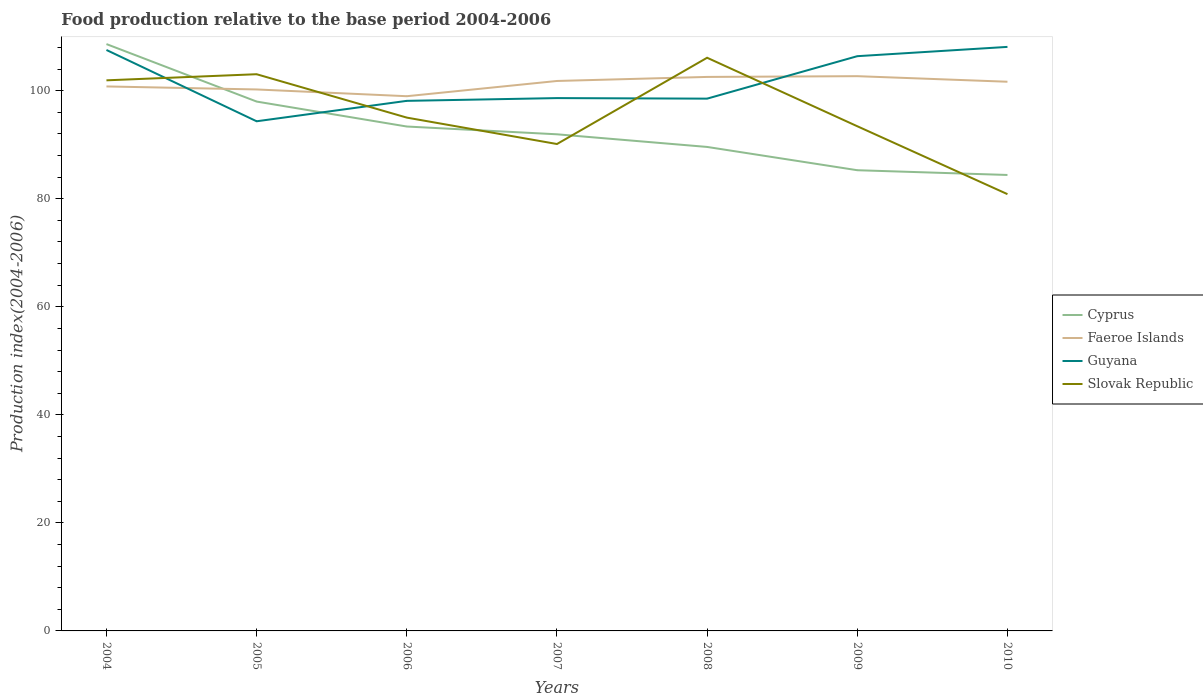Does the line corresponding to Guyana intersect with the line corresponding to Faeroe Islands?
Provide a short and direct response. Yes. Is the number of lines equal to the number of legend labels?
Give a very brief answer. Yes. Across all years, what is the maximum food production index in Cyprus?
Offer a terse response. 84.4. In which year was the food production index in Slovak Republic maximum?
Your answer should be compact. 2010. What is the total food production index in Slovak Republic in the graph?
Give a very brief answer. 1.6. What is the difference between the highest and the second highest food production index in Faeroe Islands?
Provide a succinct answer. 3.71. Does the graph contain grids?
Keep it short and to the point. No. How many legend labels are there?
Keep it short and to the point. 4. What is the title of the graph?
Your response must be concise. Food production relative to the base period 2004-2006. What is the label or title of the X-axis?
Make the answer very short. Years. What is the label or title of the Y-axis?
Ensure brevity in your answer.  Production index(2004-2006). What is the Production index(2004-2006) of Cyprus in 2004?
Offer a very short reply. 108.63. What is the Production index(2004-2006) in Faeroe Islands in 2004?
Ensure brevity in your answer.  100.79. What is the Production index(2004-2006) in Guyana in 2004?
Your answer should be very brief. 107.54. What is the Production index(2004-2006) in Slovak Republic in 2004?
Provide a succinct answer. 101.92. What is the Production index(2004-2006) of Cyprus in 2005?
Offer a very short reply. 97.99. What is the Production index(2004-2006) of Faeroe Islands in 2005?
Provide a succinct answer. 100.23. What is the Production index(2004-2006) in Guyana in 2005?
Provide a short and direct response. 94.34. What is the Production index(2004-2006) of Slovak Republic in 2005?
Make the answer very short. 103.05. What is the Production index(2004-2006) in Cyprus in 2006?
Provide a succinct answer. 93.37. What is the Production index(2004-2006) of Faeroe Islands in 2006?
Your answer should be compact. 98.98. What is the Production index(2004-2006) of Guyana in 2006?
Make the answer very short. 98.12. What is the Production index(2004-2006) of Slovak Republic in 2006?
Provide a short and direct response. 95.02. What is the Production index(2004-2006) in Cyprus in 2007?
Make the answer very short. 91.93. What is the Production index(2004-2006) in Faeroe Islands in 2007?
Your response must be concise. 101.8. What is the Production index(2004-2006) in Guyana in 2007?
Ensure brevity in your answer.  98.63. What is the Production index(2004-2006) of Slovak Republic in 2007?
Keep it short and to the point. 90.13. What is the Production index(2004-2006) in Cyprus in 2008?
Your response must be concise. 89.59. What is the Production index(2004-2006) of Faeroe Islands in 2008?
Give a very brief answer. 102.55. What is the Production index(2004-2006) in Guyana in 2008?
Keep it short and to the point. 98.53. What is the Production index(2004-2006) in Slovak Republic in 2008?
Provide a short and direct response. 106.1. What is the Production index(2004-2006) in Cyprus in 2009?
Your answer should be very brief. 85.28. What is the Production index(2004-2006) of Faeroe Islands in 2009?
Your response must be concise. 102.69. What is the Production index(2004-2006) of Guyana in 2009?
Make the answer very short. 106.39. What is the Production index(2004-2006) in Slovak Republic in 2009?
Offer a very short reply. 93.42. What is the Production index(2004-2006) in Cyprus in 2010?
Make the answer very short. 84.4. What is the Production index(2004-2006) in Faeroe Islands in 2010?
Make the answer very short. 101.66. What is the Production index(2004-2006) in Guyana in 2010?
Your response must be concise. 108.11. What is the Production index(2004-2006) in Slovak Republic in 2010?
Ensure brevity in your answer.  80.85. Across all years, what is the maximum Production index(2004-2006) of Cyprus?
Offer a very short reply. 108.63. Across all years, what is the maximum Production index(2004-2006) of Faeroe Islands?
Your answer should be compact. 102.69. Across all years, what is the maximum Production index(2004-2006) of Guyana?
Provide a succinct answer. 108.11. Across all years, what is the maximum Production index(2004-2006) of Slovak Republic?
Provide a short and direct response. 106.1. Across all years, what is the minimum Production index(2004-2006) of Cyprus?
Your answer should be compact. 84.4. Across all years, what is the minimum Production index(2004-2006) of Faeroe Islands?
Ensure brevity in your answer.  98.98. Across all years, what is the minimum Production index(2004-2006) in Guyana?
Your answer should be compact. 94.34. Across all years, what is the minimum Production index(2004-2006) of Slovak Republic?
Your answer should be compact. 80.85. What is the total Production index(2004-2006) of Cyprus in the graph?
Provide a succinct answer. 651.19. What is the total Production index(2004-2006) in Faeroe Islands in the graph?
Make the answer very short. 708.7. What is the total Production index(2004-2006) of Guyana in the graph?
Offer a terse response. 711.66. What is the total Production index(2004-2006) in Slovak Republic in the graph?
Offer a terse response. 670.49. What is the difference between the Production index(2004-2006) in Cyprus in 2004 and that in 2005?
Your answer should be very brief. 10.64. What is the difference between the Production index(2004-2006) of Faeroe Islands in 2004 and that in 2005?
Provide a short and direct response. 0.56. What is the difference between the Production index(2004-2006) of Guyana in 2004 and that in 2005?
Provide a short and direct response. 13.2. What is the difference between the Production index(2004-2006) of Slovak Republic in 2004 and that in 2005?
Offer a very short reply. -1.13. What is the difference between the Production index(2004-2006) of Cyprus in 2004 and that in 2006?
Provide a short and direct response. 15.26. What is the difference between the Production index(2004-2006) of Faeroe Islands in 2004 and that in 2006?
Give a very brief answer. 1.81. What is the difference between the Production index(2004-2006) of Guyana in 2004 and that in 2006?
Give a very brief answer. 9.42. What is the difference between the Production index(2004-2006) in Slovak Republic in 2004 and that in 2006?
Provide a succinct answer. 6.9. What is the difference between the Production index(2004-2006) in Cyprus in 2004 and that in 2007?
Give a very brief answer. 16.7. What is the difference between the Production index(2004-2006) of Faeroe Islands in 2004 and that in 2007?
Ensure brevity in your answer.  -1.01. What is the difference between the Production index(2004-2006) in Guyana in 2004 and that in 2007?
Your answer should be compact. 8.91. What is the difference between the Production index(2004-2006) of Slovak Republic in 2004 and that in 2007?
Offer a terse response. 11.79. What is the difference between the Production index(2004-2006) of Cyprus in 2004 and that in 2008?
Make the answer very short. 19.04. What is the difference between the Production index(2004-2006) in Faeroe Islands in 2004 and that in 2008?
Give a very brief answer. -1.76. What is the difference between the Production index(2004-2006) in Guyana in 2004 and that in 2008?
Provide a short and direct response. 9.01. What is the difference between the Production index(2004-2006) in Slovak Republic in 2004 and that in 2008?
Provide a succinct answer. -4.18. What is the difference between the Production index(2004-2006) in Cyprus in 2004 and that in 2009?
Provide a short and direct response. 23.35. What is the difference between the Production index(2004-2006) in Guyana in 2004 and that in 2009?
Offer a terse response. 1.15. What is the difference between the Production index(2004-2006) of Cyprus in 2004 and that in 2010?
Your response must be concise. 24.23. What is the difference between the Production index(2004-2006) in Faeroe Islands in 2004 and that in 2010?
Ensure brevity in your answer.  -0.87. What is the difference between the Production index(2004-2006) in Guyana in 2004 and that in 2010?
Ensure brevity in your answer.  -0.57. What is the difference between the Production index(2004-2006) in Slovak Republic in 2004 and that in 2010?
Offer a very short reply. 21.07. What is the difference between the Production index(2004-2006) of Cyprus in 2005 and that in 2006?
Provide a succinct answer. 4.62. What is the difference between the Production index(2004-2006) of Faeroe Islands in 2005 and that in 2006?
Provide a short and direct response. 1.25. What is the difference between the Production index(2004-2006) in Guyana in 2005 and that in 2006?
Offer a very short reply. -3.78. What is the difference between the Production index(2004-2006) in Slovak Republic in 2005 and that in 2006?
Provide a short and direct response. 8.03. What is the difference between the Production index(2004-2006) of Cyprus in 2005 and that in 2007?
Your response must be concise. 6.06. What is the difference between the Production index(2004-2006) of Faeroe Islands in 2005 and that in 2007?
Make the answer very short. -1.57. What is the difference between the Production index(2004-2006) of Guyana in 2005 and that in 2007?
Your answer should be very brief. -4.29. What is the difference between the Production index(2004-2006) in Slovak Republic in 2005 and that in 2007?
Offer a very short reply. 12.92. What is the difference between the Production index(2004-2006) of Faeroe Islands in 2005 and that in 2008?
Your response must be concise. -2.32. What is the difference between the Production index(2004-2006) in Guyana in 2005 and that in 2008?
Your answer should be very brief. -4.19. What is the difference between the Production index(2004-2006) in Slovak Republic in 2005 and that in 2008?
Ensure brevity in your answer.  -3.05. What is the difference between the Production index(2004-2006) of Cyprus in 2005 and that in 2009?
Your answer should be compact. 12.71. What is the difference between the Production index(2004-2006) in Faeroe Islands in 2005 and that in 2009?
Provide a succinct answer. -2.46. What is the difference between the Production index(2004-2006) of Guyana in 2005 and that in 2009?
Keep it short and to the point. -12.05. What is the difference between the Production index(2004-2006) of Slovak Republic in 2005 and that in 2009?
Give a very brief answer. 9.63. What is the difference between the Production index(2004-2006) in Cyprus in 2005 and that in 2010?
Keep it short and to the point. 13.59. What is the difference between the Production index(2004-2006) of Faeroe Islands in 2005 and that in 2010?
Give a very brief answer. -1.43. What is the difference between the Production index(2004-2006) of Guyana in 2005 and that in 2010?
Ensure brevity in your answer.  -13.77. What is the difference between the Production index(2004-2006) of Slovak Republic in 2005 and that in 2010?
Give a very brief answer. 22.2. What is the difference between the Production index(2004-2006) of Cyprus in 2006 and that in 2007?
Provide a short and direct response. 1.44. What is the difference between the Production index(2004-2006) of Faeroe Islands in 2006 and that in 2007?
Make the answer very short. -2.82. What is the difference between the Production index(2004-2006) in Guyana in 2006 and that in 2007?
Offer a very short reply. -0.51. What is the difference between the Production index(2004-2006) in Slovak Republic in 2006 and that in 2007?
Make the answer very short. 4.89. What is the difference between the Production index(2004-2006) of Cyprus in 2006 and that in 2008?
Offer a terse response. 3.78. What is the difference between the Production index(2004-2006) in Faeroe Islands in 2006 and that in 2008?
Ensure brevity in your answer.  -3.57. What is the difference between the Production index(2004-2006) of Guyana in 2006 and that in 2008?
Offer a very short reply. -0.41. What is the difference between the Production index(2004-2006) of Slovak Republic in 2006 and that in 2008?
Offer a very short reply. -11.08. What is the difference between the Production index(2004-2006) of Cyprus in 2006 and that in 2009?
Give a very brief answer. 8.09. What is the difference between the Production index(2004-2006) of Faeroe Islands in 2006 and that in 2009?
Your answer should be very brief. -3.71. What is the difference between the Production index(2004-2006) in Guyana in 2006 and that in 2009?
Ensure brevity in your answer.  -8.27. What is the difference between the Production index(2004-2006) in Cyprus in 2006 and that in 2010?
Offer a terse response. 8.97. What is the difference between the Production index(2004-2006) of Faeroe Islands in 2006 and that in 2010?
Keep it short and to the point. -2.68. What is the difference between the Production index(2004-2006) in Guyana in 2006 and that in 2010?
Offer a terse response. -9.99. What is the difference between the Production index(2004-2006) of Slovak Republic in 2006 and that in 2010?
Your response must be concise. 14.17. What is the difference between the Production index(2004-2006) of Cyprus in 2007 and that in 2008?
Your answer should be compact. 2.34. What is the difference between the Production index(2004-2006) in Faeroe Islands in 2007 and that in 2008?
Ensure brevity in your answer.  -0.75. What is the difference between the Production index(2004-2006) in Guyana in 2007 and that in 2008?
Give a very brief answer. 0.1. What is the difference between the Production index(2004-2006) of Slovak Republic in 2007 and that in 2008?
Your answer should be very brief. -15.97. What is the difference between the Production index(2004-2006) of Cyprus in 2007 and that in 2009?
Provide a short and direct response. 6.65. What is the difference between the Production index(2004-2006) in Faeroe Islands in 2007 and that in 2009?
Your answer should be compact. -0.89. What is the difference between the Production index(2004-2006) of Guyana in 2007 and that in 2009?
Offer a very short reply. -7.76. What is the difference between the Production index(2004-2006) in Slovak Republic in 2007 and that in 2009?
Offer a terse response. -3.29. What is the difference between the Production index(2004-2006) in Cyprus in 2007 and that in 2010?
Keep it short and to the point. 7.53. What is the difference between the Production index(2004-2006) of Faeroe Islands in 2007 and that in 2010?
Ensure brevity in your answer.  0.14. What is the difference between the Production index(2004-2006) in Guyana in 2007 and that in 2010?
Your answer should be compact. -9.48. What is the difference between the Production index(2004-2006) in Slovak Republic in 2007 and that in 2010?
Your response must be concise. 9.28. What is the difference between the Production index(2004-2006) in Cyprus in 2008 and that in 2009?
Provide a short and direct response. 4.31. What is the difference between the Production index(2004-2006) in Faeroe Islands in 2008 and that in 2009?
Make the answer very short. -0.14. What is the difference between the Production index(2004-2006) of Guyana in 2008 and that in 2009?
Offer a very short reply. -7.86. What is the difference between the Production index(2004-2006) in Slovak Republic in 2008 and that in 2009?
Make the answer very short. 12.68. What is the difference between the Production index(2004-2006) of Cyprus in 2008 and that in 2010?
Your answer should be very brief. 5.19. What is the difference between the Production index(2004-2006) in Faeroe Islands in 2008 and that in 2010?
Your answer should be compact. 0.89. What is the difference between the Production index(2004-2006) of Guyana in 2008 and that in 2010?
Your answer should be very brief. -9.58. What is the difference between the Production index(2004-2006) of Slovak Republic in 2008 and that in 2010?
Give a very brief answer. 25.25. What is the difference between the Production index(2004-2006) in Cyprus in 2009 and that in 2010?
Offer a terse response. 0.88. What is the difference between the Production index(2004-2006) of Faeroe Islands in 2009 and that in 2010?
Your answer should be compact. 1.03. What is the difference between the Production index(2004-2006) of Guyana in 2009 and that in 2010?
Keep it short and to the point. -1.72. What is the difference between the Production index(2004-2006) in Slovak Republic in 2009 and that in 2010?
Your answer should be compact. 12.57. What is the difference between the Production index(2004-2006) in Cyprus in 2004 and the Production index(2004-2006) in Guyana in 2005?
Provide a succinct answer. 14.29. What is the difference between the Production index(2004-2006) of Cyprus in 2004 and the Production index(2004-2006) of Slovak Republic in 2005?
Your answer should be very brief. 5.58. What is the difference between the Production index(2004-2006) in Faeroe Islands in 2004 and the Production index(2004-2006) in Guyana in 2005?
Provide a short and direct response. 6.45. What is the difference between the Production index(2004-2006) of Faeroe Islands in 2004 and the Production index(2004-2006) of Slovak Republic in 2005?
Make the answer very short. -2.26. What is the difference between the Production index(2004-2006) in Guyana in 2004 and the Production index(2004-2006) in Slovak Republic in 2005?
Your response must be concise. 4.49. What is the difference between the Production index(2004-2006) of Cyprus in 2004 and the Production index(2004-2006) of Faeroe Islands in 2006?
Provide a short and direct response. 9.65. What is the difference between the Production index(2004-2006) in Cyprus in 2004 and the Production index(2004-2006) in Guyana in 2006?
Offer a very short reply. 10.51. What is the difference between the Production index(2004-2006) in Cyprus in 2004 and the Production index(2004-2006) in Slovak Republic in 2006?
Provide a short and direct response. 13.61. What is the difference between the Production index(2004-2006) in Faeroe Islands in 2004 and the Production index(2004-2006) in Guyana in 2006?
Provide a succinct answer. 2.67. What is the difference between the Production index(2004-2006) in Faeroe Islands in 2004 and the Production index(2004-2006) in Slovak Republic in 2006?
Make the answer very short. 5.77. What is the difference between the Production index(2004-2006) of Guyana in 2004 and the Production index(2004-2006) of Slovak Republic in 2006?
Keep it short and to the point. 12.52. What is the difference between the Production index(2004-2006) in Cyprus in 2004 and the Production index(2004-2006) in Faeroe Islands in 2007?
Your answer should be very brief. 6.83. What is the difference between the Production index(2004-2006) of Cyprus in 2004 and the Production index(2004-2006) of Slovak Republic in 2007?
Your answer should be compact. 18.5. What is the difference between the Production index(2004-2006) in Faeroe Islands in 2004 and the Production index(2004-2006) in Guyana in 2007?
Provide a short and direct response. 2.16. What is the difference between the Production index(2004-2006) of Faeroe Islands in 2004 and the Production index(2004-2006) of Slovak Republic in 2007?
Make the answer very short. 10.66. What is the difference between the Production index(2004-2006) in Guyana in 2004 and the Production index(2004-2006) in Slovak Republic in 2007?
Offer a very short reply. 17.41. What is the difference between the Production index(2004-2006) in Cyprus in 2004 and the Production index(2004-2006) in Faeroe Islands in 2008?
Offer a very short reply. 6.08. What is the difference between the Production index(2004-2006) of Cyprus in 2004 and the Production index(2004-2006) of Guyana in 2008?
Your response must be concise. 10.1. What is the difference between the Production index(2004-2006) in Cyprus in 2004 and the Production index(2004-2006) in Slovak Republic in 2008?
Your answer should be compact. 2.53. What is the difference between the Production index(2004-2006) in Faeroe Islands in 2004 and the Production index(2004-2006) in Guyana in 2008?
Offer a terse response. 2.26. What is the difference between the Production index(2004-2006) in Faeroe Islands in 2004 and the Production index(2004-2006) in Slovak Republic in 2008?
Ensure brevity in your answer.  -5.31. What is the difference between the Production index(2004-2006) of Guyana in 2004 and the Production index(2004-2006) of Slovak Republic in 2008?
Make the answer very short. 1.44. What is the difference between the Production index(2004-2006) of Cyprus in 2004 and the Production index(2004-2006) of Faeroe Islands in 2009?
Make the answer very short. 5.94. What is the difference between the Production index(2004-2006) in Cyprus in 2004 and the Production index(2004-2006) in Guyana in 2009?
Offer a very short reply. 2.24. What is the difference between the Production index(2004-2006) of Cyprus in 2004 and the Production index(2004-2006) of Slovak Republic in 2009?
Your answer should be very brief. 15.21. What is the difference between the Production index(2004-2006) of Faeroe Islands in 2004 and the Production index(2004-2006) of Guyana in 2009?
Your answer should be compact. -5.6. What is the difference between the Production index(2004-2006) of Faeroe Islands in 2004 and the Production index(2004-2006) of Slovak Republic in 2009?
Offer a terse response. 7.37. What is the difference between the Production index(2004-2006) in Guyana in 2004 and the Production index(2004-2006) in Slovak Republic in 2009?
Your answer should be compact. 14.12. What is the difference between the Production index(2004-2006) of Cyprus in 2004 and the Production index(2004-2006) of Faeroe Islands in 2010?
Your response must be concise. 6.97. What is the difference between the Production index(2004-2006) of Cyprus in 2004 and the Production index(2004-2006) of Guyana in 2010?
Keep it short and to the point. 0.52. What is the difference between the Production index(2004-2006) of Cyprus in 2004 and the Production index(2004-2006) of Slovak Republic in 2010?
Your answer should be very brief. 27.78. What is the difference between the Production index(2004-2006) of Faeroe Islands in 2004 and the Production index(2004-2006) of Guyana in 2010?
Ensure brevity in your answer.  -7.32. What is the difference between the Production index(2004-2006) of Faeroe Islands in 2004 and the Production index(2004-2006) of Slovak Republic in 2010?
Offer a terse response. 19.94. What is the difference between the Production index(2004-2006) of Guyana in 2004 and the Production index(2004-2006) of Slovak Republic in 2010?
Keep it short and to the point. 26.69. What is the difference between the Production index(2004-2006) of Cyprus in 2005 and the Production index(2004-2006) of Faeroe Islands in 2006?
Your response must be concise. -0.99. What is the difference between the Production index(2004-2006) of Cyprus in 2005 and the Production index(2004-2006) of Guyana in 2006?
Offer a very short reply. -0.13. What is the difference between the Production index(2004-2006) in Cyprus in 2005 and the Production index(2004-2006) in Slovak Republic in 2006?
Ensure brevity in your answer.  2.97. What is the difference between the Production index(2004-2006) of Faeroe Islands in 2005 and the Production index(2004-2006) of Guyana in 2006?
Give a very brief answer. 2.11. What is the difference between the Production index(2004-2006) of Faeroe Islands in 2005 and the Production index(2004-2006) of Slovak Republic in 2006?
Offer a very short reply. 5.21. What is the difference between the Production index(2004-2006) in Guyana in 2005 and the Production index(2004-2006) in Slovak Republic in 2006?
Provide a succinct answer. -0.68. What is the difference between the Production index(2004-2006) in Cyprus in 2005 and the Production index(2004-2006) in Faeroe Islands in 2007?
Provide a succinct answer. -3.81. What is the difference between the Production index(2004-2006) of Cyprus in 2005 and the Production index(2004-2006) of Guyana in 2007?
Offer a very short reply. -0.64. What is the difference between the Production index(2004-2006) in Cyprus in 2005 and the Production index(2004-2006) in Slovak Republic in 2007?
Provide a short and direct response. 7.86. What is the difference between the Production index(2004-2006) of Faeroe Islands in 2005 and the Production index(2004-2006) of Guyana in 2007?
Provide a short and direct response. 1.6. What is the difference between the Production index(2004-2006) in Guyana in 2005 and the Production index(2004-2006) in Slovak Republic in 2007?
Offer a terse response. 4.21. What is the difference between the Production index(2004-2006) in Cyprus in 2005 and the Production index(2004-2006) in Faeroe Islands in 2008?
Offer a very short reply. -4.56. What is the difference between the Production index(2004-2006) of Cyprus in 2005 and the Production index(2004-2006) of Guyana in 2008?
Ensure brevity in your answer.  -0.54. What is the difference between the Production index(2004-2006) of Cyprus in 2005 and the Production index(2004-2006) of Slovak Republic in 2008?
Ensure brevity in your answer.  -8.11. What is the difference between the Production index(2004-2006) of Faeroe Islands in 2005 and the Production index(2004-2006) of Slovak Republic in 2008?
Offer a terse response. -5.87. What is the difference between the Production index(2004-2006) in Guyana in 2005 and the Production index(2004-2006) in Slovak Republic in 2008?
Provide a short and direct response. -11.76. What is the difference between the Production index(2004-2006) in Cyprus in 2005 and the Production index(2004-2006) in Guyana in 2009?
Keep it short and to the point. -8.4. What is the difference between the Production index(2004-2006) of Cyprus in 2005 and the Production index(2004-2006) of Slovak Republic in 2009?
Your answer should be compact. 4.57. What is the difference between the Production index(2004-2006) of Faeroe Islands in 2005 and the Production index(2004-2006) of Guyana in 2009?
Provide a succinct answer. -6.16. What is the difference between the Production index(2004-2006) in Faeroe Islands in 2005 and the Production index(2004-2006) in Slovak Republic in 2009?
Give a very brief answer. 6.81. What is the difference between the Production index(2004-2006) in Cyprus in 2005 and the Production index(2004-2006) in Faeroe Islands in 2010?
Offer a terse response. -3.67. What is the difference between the Production index(2004-2006) of Cyprus in 2005 and the Production index(2004-2006) of Guyana in 2010?
Ensure brevity in your answer.  -10.12. What is the difference between the Production index(2004-2006) in Cyprus in 2005 and the Production index(2004-2006) in Slovak Republic in 2010?
Keep it short and to the point. 17.14. What is the difference between the Production index(2004-2006) in Faeroe Islands in 2005 and the Production index(2004-2006) in Guyana in 2010?
Ensure brevity in your answer.  -7.88. What is the difference between the Production index(2004-2006) in Faeroe Islands in 2005 and the Production index(2004-2006) in Slovak Republic in 2010?
Provide a short and direct response. 19.38. What is the difference between the Production index(2004-2006) in Guyana in 2005 and the Production index(2004-2006) in Slovak Republic in 2010?
Offer a very short reply. 13.49. What is the difference between the Production index(2004-2006) of Cyprus in 2006 and the Production index(2004-2006) of Faeroe Islands in 2007?
Make the answer very short. -8.43. What is the difference between the Production index(2004-2006) of Cyprus in 2006 and the Production index(2004-2006) of Guyana in 2007?
Your answer should be compact. -5.26. What is the difference between the Production index(2004-2006) in Cyprus in 2006 and the Production index(2004-2006) in Slovak Republic in 2007?
Provide a succinct answer. 3.24. What is the difference between the Production index(2004-2006) in Faeroe Islands in 2006 and the Production index(2004-2006) in Guyana in 2007?
Your answer should be compact. 0.35. What is the difference between the Production index(2004-2006) of Faeroe Islands in 2006 and the Production index(2004-2006) of Slovak Republic in 2007?
Ensure brevity in your answer.  8.85. What is the difference between the Production index(2004-2006) in Guyana in 2006 and the Production index(2004-2006) in Slovak Republic in 2007?
Offer a terse response. 7.99. What is the difference between the Production index(2004-2006) in Cyprus in 2006 and the Production index(2004-2006) in Faeroe Islands in 2008?
Keep it short and to the point. -9.18. What is the difference between the Production index(2004-2006) of Cyprus in 2006 and the Production index(2004-2006) of Guyana in 2008?
Keep it short and to the point. -5.16. What is the difference between the Production index(2004-2006) of Cyprus in 2006 and the Production index(2004-2006) of Slovak Republic in 2008?
Provide a succinct answer. -12.73. What is the difference between the Production index(2004-2006) in Faeroe Islands in 2006 and the Production index(2004-2006) in Guyana in 2008?
Give a very brief answer. 0.45. What is the difference between the Production index(2004-2006) of Faeroe Islands in 2006 and the Production index(2004-2006) of Slovak Republic in 2008?
Provide a short and direct response. -7.12. What is the difference between the Production index(2004-2006) of Guyana in 2006 and the Production index(2004-2006) of Slovak Republic in 2008?
Provide a succinct answer. -7.98. What is the difference between the Production index(2004-2006) of Cyprus in 2006 and the Production index(2004-2006) of Faeroe Islands in 2009?
Make the answer very short. -9.32. What is the difference between the Production index(2004-2006) in Cyprus in 2006 and the Production index(2004-2006) in Guyana in 2009?
Ensure brevity in your answer.  -13.02. What is the difference between the Production index(2004-2006) of Faeroe Islands in 2006 and the Production index(2004-2006) of Guyana in 2009?
Provide a short and direct response. -7.41. What is the difference between the Production index(2004-2006) in Faeroe Islands in 2006 and the Production index(2004-2006) in Slovak Republic in 2009?
Provide a succinct answer. 5.56. What is the difference between the Production index(2004-2006) in Cyprus in 2006 and the Production index(2004-2006) in Faeroe Islands in 2010?
Ensure brevity in your answer.  -8.29. What is the difference between the Production index(2004-2006) of Cyprus in 2006 and the Production index(2004-2006) of Guyana in 2010?
Your answer should be very brief. -14.74. What is the difference between the Production index(2004-2006) of Cyprus in 2006 and the Production index(2004-2006) of Slovak Republic in 2010?
Make the answer very short. 12.52. What is the difference between the Production index(2004-2006) in Faeroe Islands in 2006 and the Production index(2004-2006) in Guyana in 2010?
Offer a very short reply. -9.13. What is the difference between the Production index(2004-2006) in Faeroe Islands in 2006 and the Production index(2004-2006) in Slovak Republic in 2010?
Ensure brevity in your answer.  18.13. What is the difference between the Production index(2004-2006) of Guyana in 2006 and the Production index(2004-2006) of Slovak Republic in 2010?
Give a very brief answer. 17.27. What is the difference between the Production index(2004-2006) of Cyprus in 2007 and the Production index(2004-2006) of Faeroe Islands in 2008?
Offer a very short reply. -10.62. What is the difference between the Production index(2004-2006) in Cyprus in 2007 and the Production index(2004-2006) in Guyana in 2008?
Your answer should be very brief. -6.6. What is the difference between the Production index(2004-2006) in Cyprus in 2007 and the Production index(2004-2006) in Slovak Republic in 2008?
Your answer should be compact. -14.17. What is the difference between the Production index(2004-2006) of Faeroe Islands in 2007 and the Production index(2004-2006) of Guyana in 2008?
Make the answer very short. 3.27. What is the difference between the Production index(2004-2006) of Guyana in 2007 and the Production index(2004-2006) of Slovak Republic in 2008?
Provide a short and direct response. -7.47. What is the difference between the Production index(2004-2006) of Cyprus in 2007 and the Production index(2004-2006) of Faeroe Islands in 2009?
Provide a succinct answer. -10.76. What is the difference between the Production index(2004-2006) in Cyprus in 2007 and the Production index(2004-2006) in Guyana in 2009?
Keep it short and to the point. -14.46. What is the difference between the Production index(2004-2006) of Cyprus in 2007 and the Production index(2004-2006) of Slovak Republic in 2009?
Ensure brevity in your answer.  -1.49. What is the difference between the Production index(2004-2006) in Faeroe Islands in 2007 and the Production index(2004-2006) in Guyana in 2009?
Keep it short and to the point. -4.59. What is the difference between the Production index(2004-2006) in Faeroe Islands in 2007 and the Production index(2004-2006) in Slovak Republic in 2009?
Give a very brief answer. 8.38. What is the difference between the Production index(2004-2006) in Guyana in 2007 and the Production index(2004-2006) in Slovak Republic in 2009?
Your answer should be compact. 5.21. What is the difference between the Production index(2004-2006) of Cyprus in 2007 and the Production index(2004-2006) of Faeroe Islands in 2010?
Your response must be concise. -9.73. What is the difference between the Production index(2004-2006) of Cyprus in 2007 and the Production index(2004-2006) of Guyana in 2010?
Keep it short and to the point. -16.18. What is the difference between the Production index(2004-2006) in Cyprus in 2007 and the Production index(2004-2006) in Slovak Republic in 2010?
Give a very brief answer. 11.08. What is the difference between the Production index(2004-2006) in Faeroe Islands in 2007 and the Production index(2004-2006) in Guyana in 2010?
Offer a very short reply. -6.31. What is the difference between the Production index(2004-2006) in Faeroe Islands in 2007 and the Production index(2004-2006) in Slovak Republic in 2010?
Your response must be concise. 20.95. What is the difference between the Production index(2004-2006) in Guyana in 2007 and the Production index(2004-2006) in Slovak Republic in 2010?
Provide a short and direct response. 17.78. What is the difference between the Production index(2004-2006) of Cyprus in 2008 and the Production index(2004-2006) of Guyana in 2009?
Keep it short and to the point. -16.8. What is the difference between the Production index(2004-2006) in Cyprus in 2008 and the Production index(2004-2006) in Slovak Republic in 2009?
Provide a succinct answer. -3.83. What is the difference between the Production index(2004-2006) of Faeroe Islands in 2008 and the Production index(2004-2006) of Guyana in 2009?
Offer a very short reply. -3.84. What is the difference between the Production index(2004-2006) in Faeroe Islands in 2008 and the Production index(2004-2006) in Slovak Republic in 2009?
Make the answer very short. 9.13. What is the difference between the Production index(2004-2006) of Guyana in 2008 and the Production index(2004-2006) of Slovak Republic in 2009?
Keep it short and to the point. 5.11. What is the difference between the Production index(2004-2006) in Cyprus in 2008 and the Production index(2004-2006) in Faeroe Islands in 2010?
Give a very brief answer. -12.07. What is the difference between the Production index(2004-2006) in Cyprus in 2008 and the Production index(2004-2006) in Guyana in 2010?
Keep it short and to the point. -18.52. What is the difference between the Production index(2004-2006) in Cyprus in 2008 and the Production index(2004-2006) in Slovak Republic in 2010?
Your answer should be compact. 8.74. What is the difference between the Production index(2004-2006) of Faeroe Islands in 2008 and the Production index(2004-2006) of Guyana in 2010?
Ensure brevity in your answer.  -5.56. What is the difference between the Production index(2004-2006) in Faeroe Islands in 2008 and the Production index(2004-2006) in Slovak Republic in 2010?
Your answer should be compact. 21.7. What is the difference between the Production index(2004-2006) in Guyana in 2008 and the Production index(2004-2006) in Slovak Republic in 2010?
Ensure brevity in your answer.  17.68. What is the difference between the Production index(2004-2006) of Cyprus in 2009 and the Production index(2004-2006) of Faeroe Islands in 2010?
Keep it short and to the point. -16.38. What is the difference between the Production index(2004-2006) of Cyprus in 2009 and the Production index(2004-2006) of Guyana in 2010?
Offer a terse response. -22.83. What is the difference between the Production index(2004-2006) of Cyprus in 2009 and the Production index(2004-2006) of Slovak Republic in 2010?
Ensure brevity in your answer.  4.43. What is the difference between the Production index(2004-2006) of Faeroe Islands in 2009 and the Production index(2004-2006) of Guyana in 2010?
Provide a succinct answer. -5.42. What is the difference between the Production index(2004-2006) in Faeroe Islands in 2009 and the Production index(2004-2006) in Slovak Republic in 2010?
Your answer should be compact. 21.84. What is the difference between the Production index(2004-2006) in Guyana in 2009 and the Production index(2004-2006) in Slovak Republic in 2010?
Give a very brief answer. 25.54. What is the average Production index(2004-2006) of Cyprus per year?
Your response must be concise. 93.03. What is the average Production index(2004-2006) in Faeroe Islands per year?
Offer a very short reply. 101.24. What is the average Production index(2004-2006) of Guyana per year?
Give a very brief answer. 101.67. What is the average Production index(2004-2006) in Slovak Republic per year?
Provide a succinct answer. 95.78. In the year 2004, what is the difference between the Production index(2004-2006) in Cyprus and Production index(2004-2006) in Faeroe Islands?
Give a very brief answer. 7.84. In the year 2004, what is the difference between the Production index(2004-2006) of Cyprus and Production index(2004-2006) of Guyana?
Offer a terse response. 1.09. In the year 2004, what is the difference between the Production index(2004-2006) of Cyprus and Production index(2004-2006) of Slovak Republic?
Provide a succinct answer. 6.71. In the year 2004, what is the difference between the Production index(2004-2006) in Faeroe Islands and Production index(2004-2006) in Guyana?
Offer a very short reply. -6.75. In the year 2004, what is the difference between the Production index(2004-2006) in Faeroe Islands and Production index(2004-2006) in Slovak Republic?
Ensure brevity in your answer.  -1.13. In the year 2004, what is the difference between the Production index(2004-2006) of Guyana and Production index(2004-2006) of Slovak Republic?
Give a very brief answer. 5.62. In the year 2005, what is the difference between the Production index(2004-2006) of Cyprus and Production index(2004-2006) of Faeroe Islands?
Provide a short and direct response. -2.24. In the year 2005, what is the difference between the Production index(2004-2006) of Cyprus and Production index(2004-2006) of Guyana?
Your response must be concise. 3.65. In the year 2005, what is the difference between the Production index(2004-2006) of Cyprus and Production index(2004-2006) of Slovak Republic?
Make the answer very short. -5.06. In the year 2005, what is the difference between the Production index(2004-2006) of Faeroe Islands and Production index(2004-2006) of Guyana?
Offer a terse response. 5.89. In the year 2005, what is the difference between the Production index(2004-2006) in Faeroe Islands and Production index(2004-2006) in Slovak Republic?
Keep it short and to the point. -2.82. In the year 2005, what is the difference between the Production index(2004-2006) in Guyana and Production index(2004-2006) in Slovak Republic?
Provide a succinct answer. -8.71. In the year 2006, what is the difference between the Production index(2004-2006) of Cyprus and Production index(2004-2006) of Faeroe Islands?
Your answer should be very brief. -5.61. In the year 2006, what is the difference between the Production index(2004-2006) of Cyprus and Production index(2004-2006) of Guyana?
Keep it short and to the point. -4.75. In the year 2006, what is the difference between the Production index(2004-2006) of Cyprus and Production index(2004-2006) of Slovak Republic?
Keep it short and to the point. -1.65. In the year 2006, what is the difference between the Production index(2004-2006) of Faeroe Islands and Production index(2004-2006) of Guyana?
Provide a succinct answer. 0.86. In the year 2006, what is the difference between the Production index(2004-2006) in Faeroe Islands and Production index(2004-2006) in Slovak Republic?
Ensure brevity in your answer.  3.96. In the year 2007, what is the difference between the Production index(2004-2006) of Cyprus and Production index(2004-2006) of Faeroe Islands?
Offer a very short reply. -9.87. In the year 2007, what is the difference between the Production index(2004-2006) of Faeroe Islands and Production index(2004-2006) of Guyana?
Give a very brief answer. 3.17. In the year 2007, what is the difference between the Production index(2004-2006) of Faeroe Islands and Production index(2004-2006) of Slovak Republic?
Give a very brief answer. 11.67. In the year 2008, what is the difference between the Production index(2004-2006) of Cyprus and Production index(2004-2006) of Faeroe Islands?
Offer a terse response. -12.96. In the year 2008, what is the difference between the Production index(2004-2006) of Cyprus and Production index(2004-2006) of Guyana?
Your answer should be compact. -8.94. In the year 2008, what is the difference between the Production index(2004-2006) of Cyprus and Production index(2004-2006) of Slovak Republic?
Your answer should be compact. -16.51. In the year 2008, what is the difference between the Production index(2004-2006) in Faeroe Islands and Production index(2004-2006) in Guyana?
Your answer should be compact. 4.02. In the year 2008, what is the difference between the Production index(2004-2006) in Faeroe Islands and Production index(2004-2006) in Slovak Republic?
Your response must be concise. -3.55. In the year 2008, what is the difference between the Production index(2004-2006) of Guyana and Production index(2004-2006) of Slovak Republic?
Give a very brief answer. -7.57. In the year 2009, what is the difference between the Production index(2004-2006) of Cyprus and Production index(2004-2006) of Faeroe Islands?
Keep it short and to the point. -17.41. In the year 2009, what is the difference between the Production index(2004-2006) in Cyprus and Production index(2004-2006) in Guyana?
Provide a short and direct response. -21.11. In the year 2009, what is the difference between the Production index(2004-2006) in Cyprus and Production index(2004-2006) in Slovak Republic?
Your answer should be very brief. -8.14. In the year 2009, what is the difference between the Production index(2004-2006) in Faeroe Islands and Production index(2004-2006) in Slovak Republic?
Ensure brevity in your answer.  9.27. In the year 2009, what is the difference between the Production index(2004-2006) in Guyana and Production index(2004-2006) in Slovak Republic?
Give a very brief answer. 12.97. In the year 2010, what is the difference between the Production index(2004-2006) of Cyprus and Production index(2004-2006) of Faeroe Islands?
Provide a succinct answer. -17.26. In the year 2010, what is the difference between the Production index(2004-2006) of Cyprus and Production index(2004-2006) of Guyana?
Offer a very short reply. -23.71. In the year 2010, what is the difference between the Production index(2004-2006) of Cyprus and Production index(2004-2006) of Slovak Republic?
Provide a short and direct response. 3.55. In the year 2010, what is the difference between the Production index(2004-2006) of Faeroe Islands and Production index(2004-2006) of Guyana?
Provide a short and direct response. -6.45. In the year 2010, what is the difference between the Production index(2004-2006) in Faeroe Islands and Production index(2004-2006) in Slovak Republic?
Offer a very short reply. 20.81. In the year 2010, what is the difference between the Production index(2004-2006) of Guyana and Production index(2004-2006) of Slovak Republic?
Your response must be concise. 27.26. What is the ratio of the Production index(2004-2006) in Cyprus in 2004 to that in 2005?
Keep it short and to the point. 1.11. What is the ratio of the Production index(2004-2006) of Faeroe Islands in 2004 to that in 2005?
Keep it short and to the point. 1.01. What is the ratio of the Production index(2004-2006) in Guyana in 2004 to that in 2005?
Provide a succinct answer. 1.14. What is the ratio of the Production index(2004-2006) in Cyprus in 2004 to that in 2006?
Offer a very short reply. 1.16. What is the ratio of the Production index(2004-2006) of Faeroe Islands in 2004 to that in 2006?
Keep it short and to the point. 1.02. What is the ratio of the Production index(2004-2006) of Guyana in 2004 to that in 2006?
Offer a terse response. 1.1. What is the ratio of the Production index(2004-2006) of Slovak Republic in 2004 to that in 2006?
Give a very brief answer. 1.07. What is the ratio of the Production index(2004-2006) of Cyprus in 2004 to that in 2007?
Offer a very short reply. 1.18. What is the ratio of the Production index(2004-2006) in Guyana in 2004 to that in 2007?
Provide a succinct answer. 1.09. What is the ratio of the Production index(2004-2006) in Slovak Republic in 2004 to that in 2007?
Your answer should be compact. 1.13. What is the ratio of the Production index(2004-2006) of Cyprus in 2004 to that in 2008?
Offer a very short reply. 1.21. What is the ratio of the Production index(2004-2006) of Faeroe Islands in 2004 to that in 2008?
Keep it short and to the point. 0.98. What is the ratio of the Production index(2004-2006) of Guyana in 2004 to that in 2008?
Give a very brief answer. 1.09. What is the ratio of the Production index(2004-2006) of Slovak Republic in 2004 to that in 2008?
Your answer should be very brief. 0.96. What is the ratio of the Production index(2004-2006) of Cyprus in 2004 to that in 2009?
Provide a short and direct response. 1.27. What is the ratio of the Production index(2004-2006) of Faeroe Islands in 2004 to that in 2009?
Offer a very short reply. 0.98. What is the ratio of the Production index(2004-2006) of Guyana in 2004 to that in 2009?
Your answer should be compact. 1.01. What is the ratio of the Production index(2004-2006) in Slovak Republic in 2004 to that in 2009?
Ensure brevity in your answer.  1.09. What is the ratio of the Production index(2004-2006) in Cyprus in 2004 to that in 2010?
Give a very brief answer. 1.29. What is the ratio of the Production index(2004-2006) in Faeroe Islands in 2004 to that in 2010?
Give a very brief answer. 0.99. What is the ratio of the Production index(2004-2006) in Guyana in 2004 to that in 2010?
Your answer should be very brief. 0.99. What is the ratio of the Production index(2004-2006) of Slovak Republic in 2004 to that in 2010?
Keep it short and to the point. 1.26. What is the ratio of the Production index(2004-2006) in Cyprus in 2005 to that in 2006?
Give a very brief answer. 1.05. What is the ratio of the Production index(2004-2006) of Faeroe Islands in 2005 to that in 2006?
Make the answer very short. 1.01. What is the ratio of the Production index(2004-2006) in Guyana in 2005 to that in 2006?
Provide a short and direct response. 0.96. What is the ratio of the Production index(2004-2006) in Slovak Republic in 2005 to that in 2006?
Your answer should be compact. 1.08. What is the ratio of the Production index(2004-2006) in Cyprus in 2005 to that in 2007?
Offer a terse response. 1.07. What is the ratio of the Production index(2004-2006) in Faeroe Islands in 2005 to that in 2007?
Offer a terse response. 0.98. What is the ratio of the Production index(2004-2006) of Guyana in 2005 to that in 2007?
Provide a succinct answer. 0.96. What is the ratio of the Production index(2004-2006) in Slovak Republic in 2005 to that in 2007?
Keep it short and to the point. 1.14. What is the ratio of the Production index(2004-2006) of Cyprus in 2005 to that in 2008?
Make the answer very short. 1.09. What is the ratio of the Production index(2004-2006) of Faeroe Islands in 2005 to that in 2008?
Your response must be concise. 0.98. What is the ratio of the Production index(2004-2006) in Guyana in 2005 to that in 2008?
Make the answer very short. 0.96. What is the ratio of the Production index(2004-2006) in Slovak Republic in 2005 to that in 2008?
Offer a terse response. 0.97. What is the ratio of the Production index(2004-2006) in Cyprus in 2005 to that in 2009?
Your answer should be compact. 1.15. What is the ratio of the Production index(2004-2006) in Guyana in 2005 to that in 2009?
Ensure brevity in your answer.  0.89. What is the ratio of the Production index(2004-2006) in Slovak Republic in 2005 to that in 2009?
Your answer should be compact. 1.1. What is the ratio of the Production index(2004-2006) in Cyprus in 2005 to that in 2010?
Provide a succinct answer. 1.16. What is the ratio of the Production index(2004-2006) in Faeroe Islands in 2005 to that in 2010?
Provide a short and direct response. 0.99. What is the ratio of the Production index(2004-2006) of Guyana in 2005 to that in 2010?
Offer a very short reply. 0.87. What is the ratio of the Production index(2004-2006) of Slovak Republic in 2005 to that in 2010?
Provide a succinct answer. 1.27. What is the ratio of the Production index(2004-2006) of Cyprus in 2006 to that in 2007?
Provide a short and direct response. 1.02. What is the ratio of the Production index(2004-2006) of Faeroe Islands in 2006 to that in 2007?
Your response must be concise. 0.97. What is the ratio of the Production index(2004-2006) of Guyana in 2006 to that in 2007?
Keep it short and to the point. 0.99. What is the ratio of the Production index(2004-2006) of Slovak Republic in 2006 to that in 2007?
Provide a succinct answer. 1.05. What is the ratio of the Production index(2004-2006) in Cyprus in 2006 to that in 2008?
Ensure brevity in your answer.  1.04. What is the ratio of the Production index(2004-2006) of Faeroe Islands in 2006 to that in 2008?
Provide a short and direct response. 0.97. What is the ratio of the Production index(2004-2006) in Slovak Republic in 2006 to that in 2008?
Offer a terse response. 0.9. What is the ratio of the Production index(2004-2006) in Cyprus in 2006 to that in 2009?
Keep it short and to the point. 1.09. What is the ratio of the Production index(2004-2006) in Faeroe Islands in 2006 to that in 2009?
Your response must be concise. 0.96. What is the ratio of the Production index(2004-2006) in Guyana in 2006 to that in 2009?
Keep it short and to the point. 0.92. What is the ratio of the Production index(2004-2006) in Slovak Republic in 2006 to that in 2009?
Your answer should be compact. 1.02. What is the ratio of the Production index(2004-2006) in Cyprus in 2006 to that in 2010?
Offer a terse response. 1.11. What is the ratio of the Production index(2004-2006) in Faeroe Islands in 2006 to that in 2010?
Ensure brevity in your answer.  0.97. What is the ratio of the Production index(2004-2006) of Guyana in 2006 to that in 2010?
Provide a short and direct response. 0.91. What is the ratio of the Production index(2004-2006) in Slovak Republic in 2006 to that in 2010?
Provide a short and direct response. 1.18. What is the ratio of the Production index(2004-2006) of Cyprus in 2007 to that in 2008?
Keep it short and to the point. 1.03. What is the ratio of the Production index(2004-2006) in Guyana in 2007 to that in 2008?
Your response must be concise. 1. What is the ratio of the Production index(2004-2006) of Slovak Republic in 2007 to that in 2008?
Offer a very short reply. 0.85. What is the ratio of the Production index(2004-2006) of Cyprus in 2007 to that in 2009?
Offer a terse response. 1.08. What is the ratio of the Production index(2004-2006) of Guyana in 2007 to that in 2009?
Make the answer very short. 0.93. What is the ratio of the Production index(2004-2006) of Slovak Republic in 2007 to that in 2009?
Offer a terse response. 0.96. What is the ratio of the Production index(2004-2006) in Cyprus in 2007 to that in 2010?
Give a very brief answer. 1.09. What is the ratio of the Production index(2004-2006) of Guyana in 2007 to that in 2010?
Offer a very short reply. 0.91. What is the ratio of the Production index(2004-2006) of Slovak Republic in 2007 to that in 2010?
Your answer should be very brief. 1.11. What is the ratio of the Production index(2004-2006) of Cyprus in 2008 to that in 2009?
Offer a very short reply. 1.05. What is the ratio of the Production index(2004-2006) in Guyana in 2008 to that in 2009?
Keep it short and to the point. 0.93. What is the ratio of the Production index(2004-2006) in Slovak Republic in 2008 to that in 2009?
Give a very brief answer. 1.14. What is the ratio of the Production index(2004-2006) in Cyprus in 2008 to that in 2010?
Your response must be concise. 1.06. What is the ratio of the Production index(2004-2006) in Faeroe Islands in 2008 to that in 2010?
Your response must be concise. 1.01. What is the ratio of the Production index(2004-2006) of Guyana in 2008 to that in 2010?
Your answer should be very brief. 0.91. What is the ratio of the Production index(2004-2006) of Slovak Republic in 2008 to that in 2010?
Ensure brevity in your answer.  1.31. What is the ratio of the Production index(2004-2006) in Cyprus in 2009 to that in 2010?
Make the answer very short. 1.01. What is the ratio of the Production index(2004-2006) of Faeroe Islands in 2009 to that in 2010?
Your answer should be compact. 1.01. What is the ratio of the Production index(2004-2006) in Guyana in 2009 to that in 2010?
Provide a short and direct response. 0.98. What is the ratio of the Production index(2004-2006) in Slovak Republic in 2009 to that in 2010?
Offer a very short reply. 1.16. What is the difference between the highest and the second highest Production index(2004-2006) of Cyprus?
Provide a succinct answer. 10.64. What is the difference between the highest and the second highest Production index(2004-2006) of Faeroe Islands?
Provide a short and direct response. 0.14. What is the difference between the highest and the second highest Production index(2004-2006) of Guyana?
Your response must be concise. 0.57. What is the difference between the highest and the second highest Production index(2004-2006) in Slovak Republic?
Keep it short and to the point. 3.05. What is the difference between the highest and the lowest Production index(2004-2006) of Cyprus?
Give a very brief answer. 24.23. What is the difference between the highest and the lowest Production index(2004-2006) in Faeroe Islands?
Keep it short and to the point. 3.71. What is the difference between the highest and the lowest Production index(2004-2006) of Guyana?
Make the answer very short. 13.77. What is the difference between the highest and the lowest Production index(2004-2006) in Slovak Republic?
Keep it short and to the point. 25.25. 